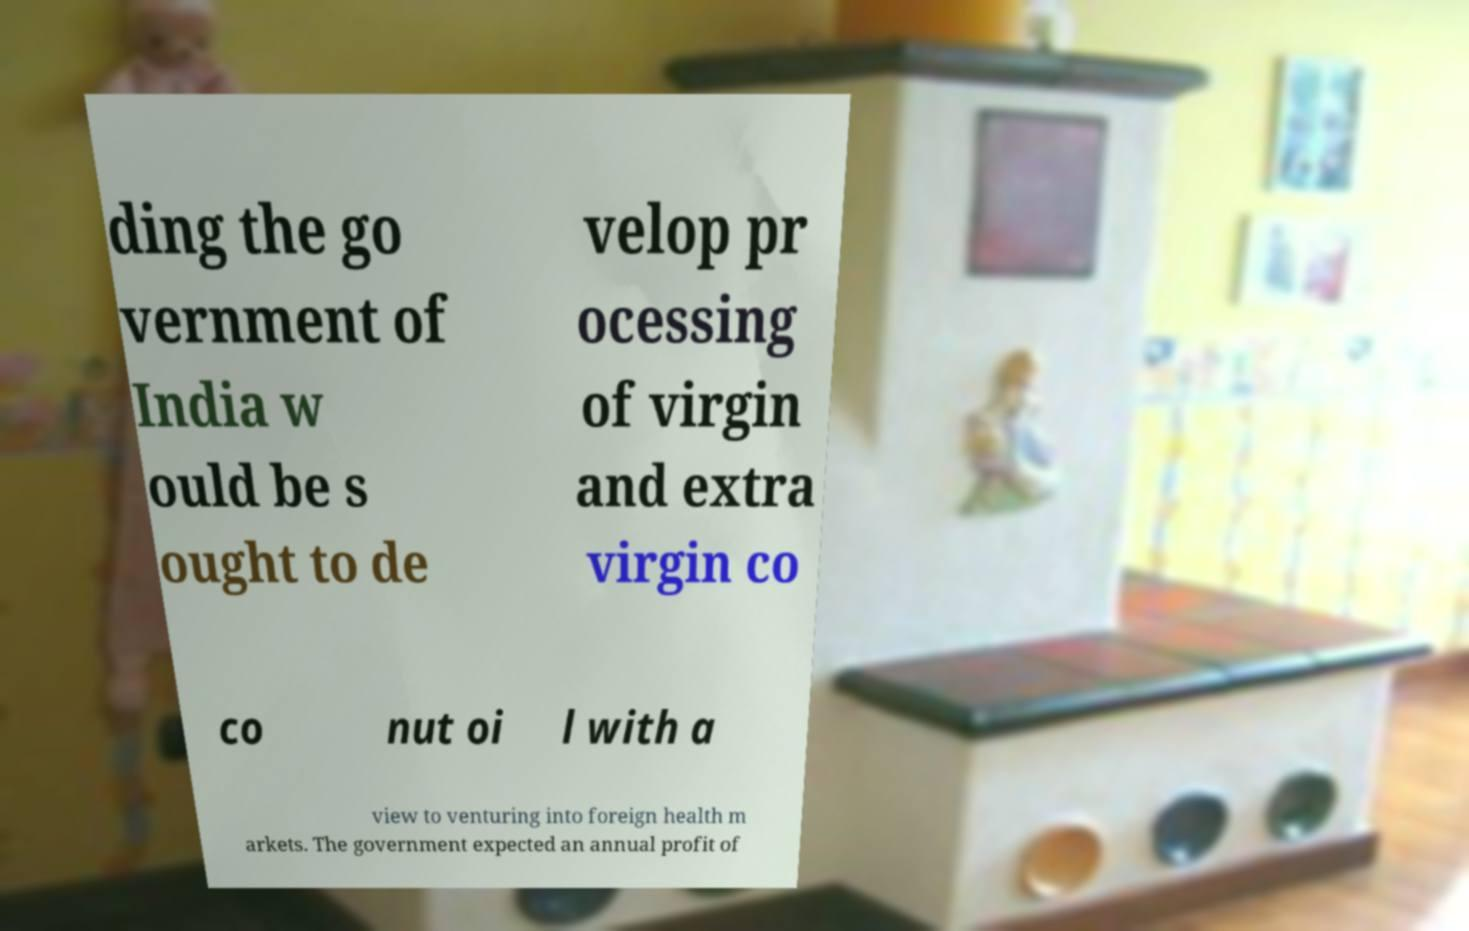Could you extract and type out the text from this image? ding the go vernment of India w ould be s ought to de velop pr ocessing of virgin and extra virgin co co nut oi l with a view to venturing into foreign health m arkets. The government expected an annual profit of 